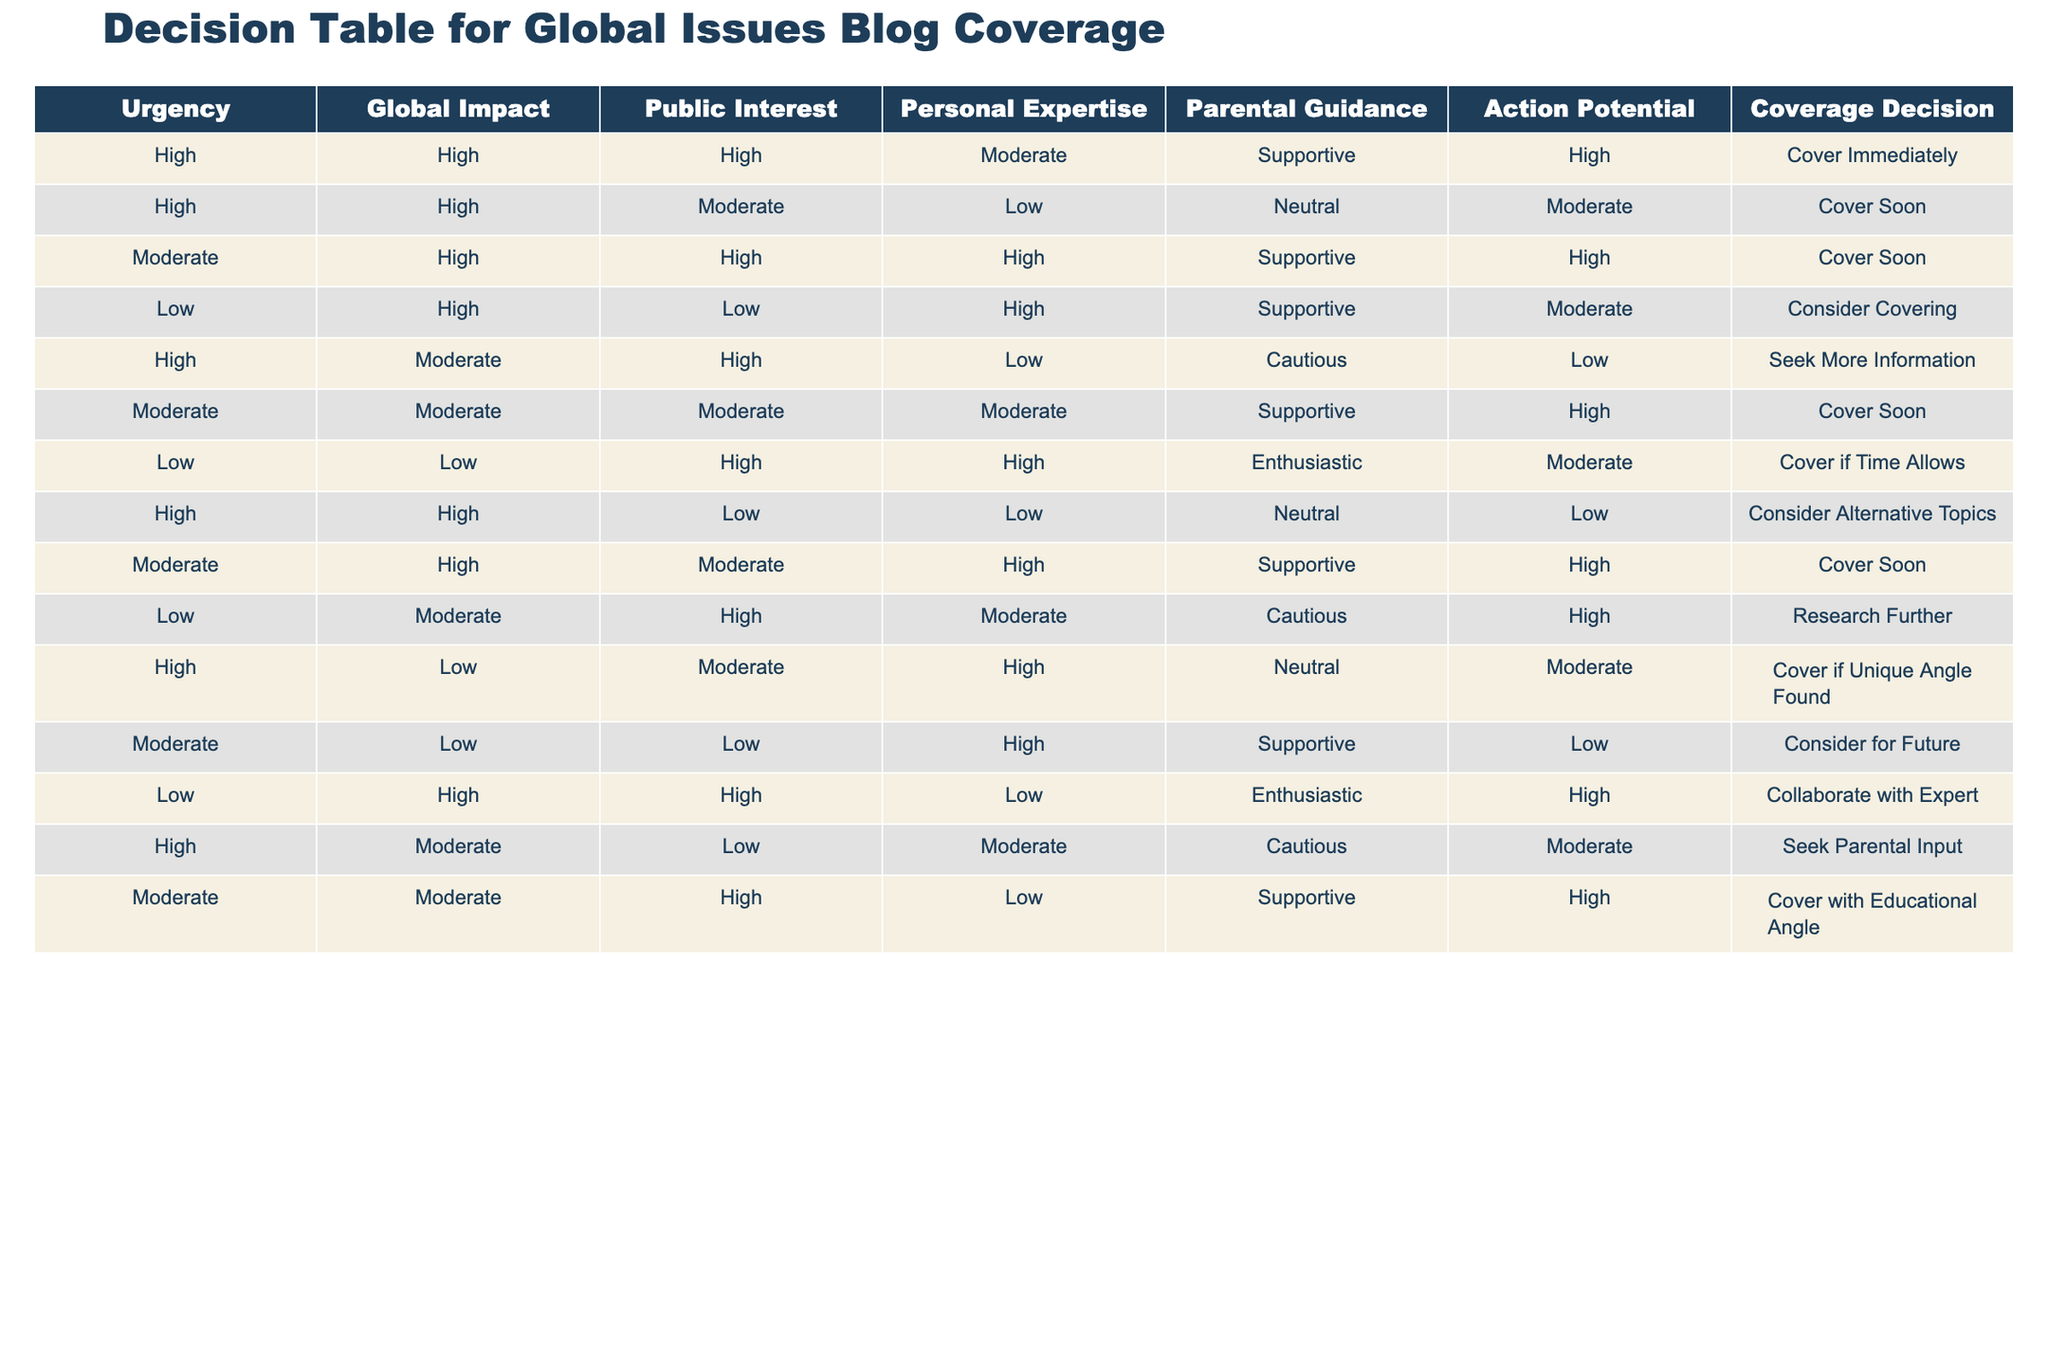What is the coverage decision for issues with high urgency and high public interest? There are two entries that meet these criteria: the first row states "Cover Immediately," and the second states "Cover Soon." Thus, the coverage decisions are "Cover Immediately" and "Cover Soon."
Answer: Cover Immediately and Cover Soon Which criterion has the most 'High' ratings among all the issues? Counting the 'High' ratings in each column: Urgency has 5, Global Impact has 6, Public Interest has 5, Personal Expertise has 3, Parental Guidance has 4, and Action Potential has 5. Thus, Global Impact has the most 'High' ratings with 6.
Answer: Global Impact Is there any issue that has a decision to "Seek More Information"? There is one issue that has the decision "Seek More Information," which is the one with criteria High - Moderate - High - Low - Neutral - Low.
Answer: Yes How many issues have a coverage decision of "Cover Soon"? There are 4 entries that have "Cover Soon" as their coverage decision. They can be found in the third, sixth, ninth, and eleventh rows.
Answer: 4 Are there any issues classified as "Consider Covering" that have a high urgency? The only row with high urgency that also has the coverage decision "Consider Covering" is the one in the fourth row, which has "Low" for Global Impact and "High" for Personal Expertise. So the answer is True.
Answer: True What is the average number of High ratings across all criteria? Count the 'High' ratings per row and sum them: High (5), Global Impact (6), Public Interest (5), Personal Expertise (3), Parental Guidance (4), and Action Potential (5) gives a total of 28. Dividing this by the number of criteria (6), the average is approximately 4.67.
Answer: 4.67 Which combination of urgency and action potential leads to "Cover Immediately"? Only one row meets this criterion: it is the first entry which has High for both urgency and action potential.
Answer: High U, High A Is there any issue that did not receive any 'High' ratings in all categories? Yes, the sixth issue in the data is the only one with 'Low' ratings across the board in urgency, global impact, public interest, personal expertise, and action potential.
Answer: Yes 